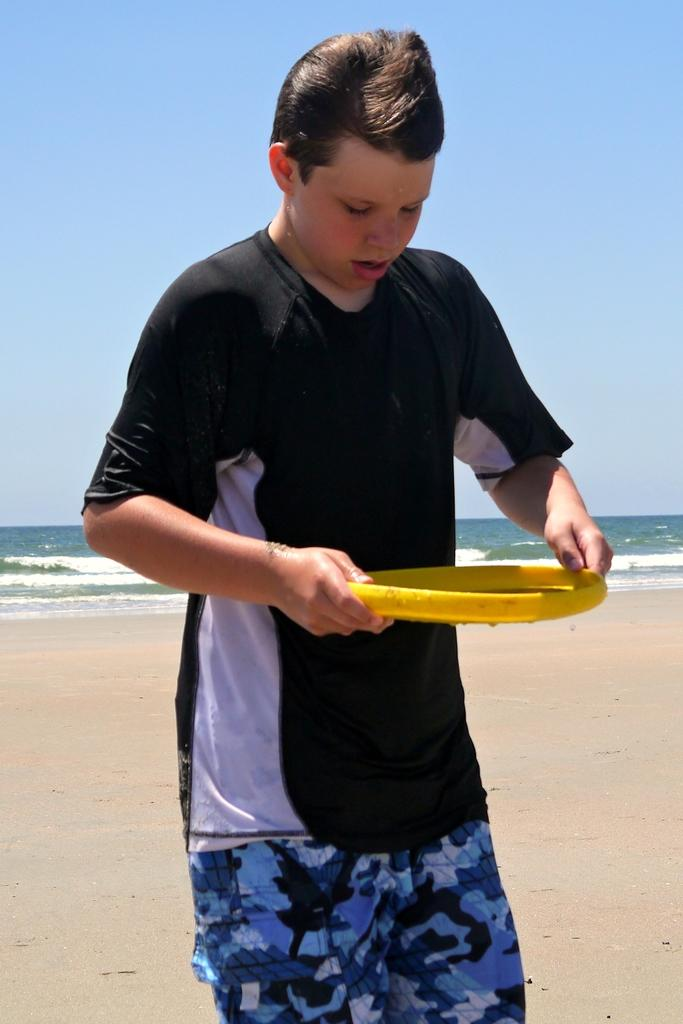What is the main subject in the foreground of the image? There is a man standing in the foreground of the image. What is the man holding in the image? The man is holding an object. What type of environment can be seen in the background of the image? There is water, sand, and the sky visible in the background of the image. How many cubs are playing with bikes in the image? There are no cubs or bikes present in the image. What time of day is it in the image, based on the hour? The provided facts do not mention the time of day or any specific hour, so it cannot be determined from the image. 